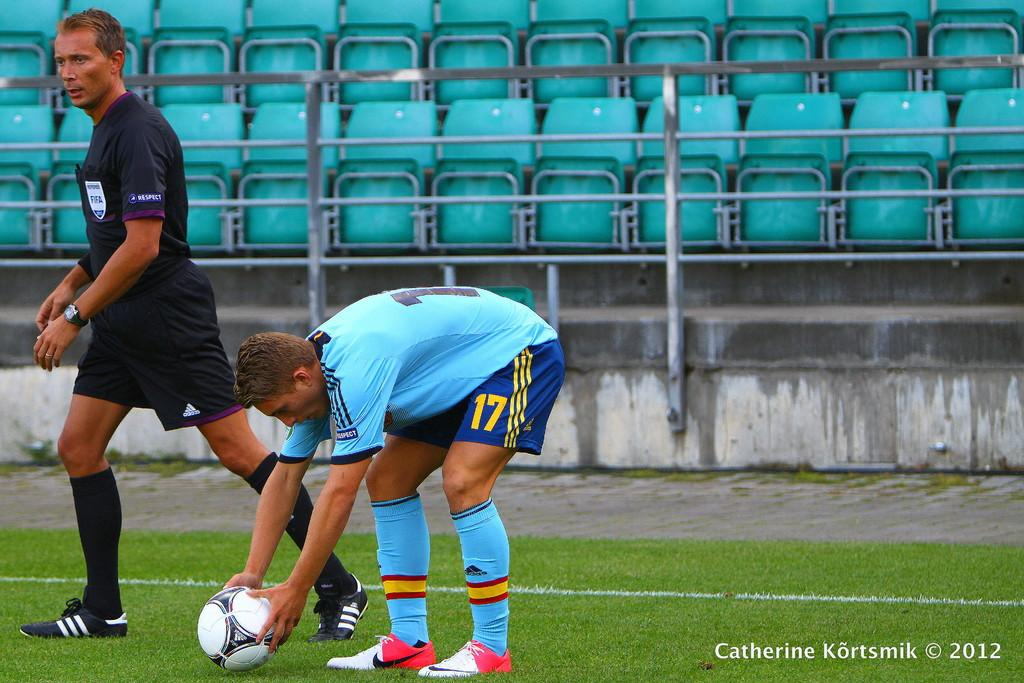What is the person in the image doing? The person is holding a ball in the image. Where is the ball located in relation to the person? The ball is on the ground. How is the person positioned in the image? The person is in the center of the image. What other person can be seen in the image? There is an umpire in the image. Where is the umpire located in the image? The umpire is on the left side of the image. What historical event is being commemorated in the image? There is no indication of a historical event being commemorated in the image. 